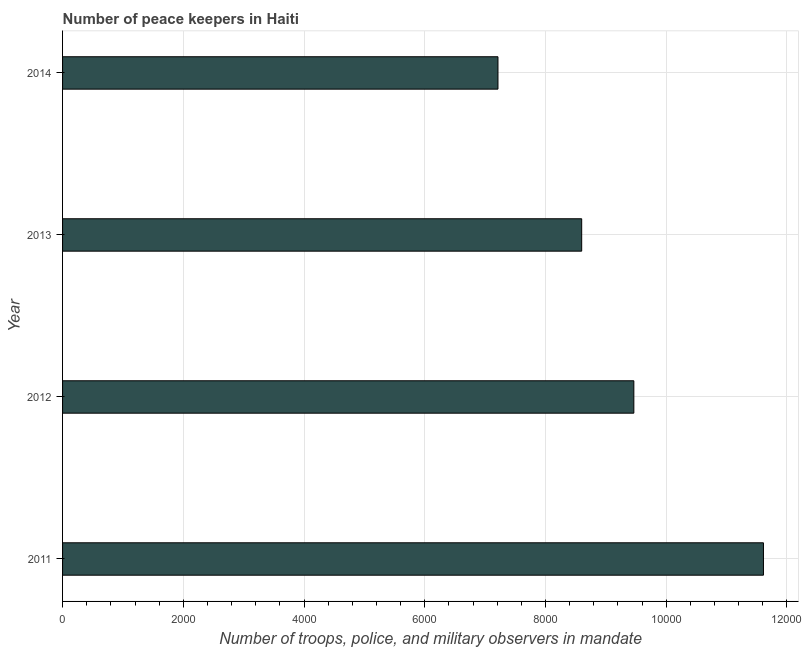Does the graph contain grids?
Make the answer very short. Yes. What is the title of the graph?
Offer a terse response. Number of peace keepers in Haiti. What is the label or title of the X-axis?
Offer a terse response. Number of troops, police, and military observers in mandate. What is the number of peace keepers in 2014?
Provide a short and direct response. 7213. Across all years, what is the maximum number of peace keepers?
Your answer should be compact. 1.16e+04. Across all years, what is the minimum number of peace keepers?
Make the answer very short. 7213. In which year was the number of peace keepers maximum?
Provide a short and direct response. 2011. In which year was the number of peace keepers minimum?
Keep it short and to the point. 2014. What is the sum of the number of peace keepers?
Provide a succinct answer. 3.69e+04. What is the difference between the number of peace keepers in 2011 and 2012?
Offer a terse response. 2147. What is the average number of peace keepers per year?
Make the answer very short. 9222. What is the median number of peace keepers?
Ensure brevity in your answer.  9032. What is the ratio of the number of peace keepers in 2012 to that in 2013?
Your response must be concise. 1.1. Is the number of peace keepers in 2011 less than that in 2014?
Your answer should be compact. No. Is the difference between the number of peace keepers in 2011 and 2014 greater than the difference between any two years?
Keep it short and to the point. Yes. What is the difference between the highest and the second highest number of peace keepers?
Make the answer very short. 2147. Is the sum of the number of peace keepers in 2012 and 2014 greater than the maximum number of peace keepers across all years?
Offer a very short reply. Yes. What is the difference between the highest and the lowest number of peace keepers?
Offer a terse response. 4398. In how many years, is the number of peace keepers greater than the average number of peace keepers taken over all years?
Offer a very short reply. 2. How many bars are there?
Offer a terse response. 4. Are all the bars in the graph horizontal?
Your response must be concise. Yes. Are the values on the major ticks of X-axis written in scientific E-notation?
Offer a terse response. No. What is the Number of troops, police, and military observers in mandate of 2011?
Ensure brevity in your answer.  1.16e+04. What is the Number of troops, police, and military observers in mandate in 2012?
Offer a terse response. 9464. What is the Number of troops, police, and military observers in mandate in 2013?
Provide a short and direct response. 8600. What is the Number of troops, police, and military observers in mandate in 2014?
Give a very brief answer. 7213. What is the difference between the Number of troops, police, and military observers in mandate in 2011 and 2012?
Provide a succinct answer. 2147. What is the difference between the Number of troops, police, and military observers in mandate in 2011 and 2013?
Give a very brief answer. 3011. What is the difference between the Number of troops, police, and military observers in mandate in 2011 and 2014?
Your answer should be very brief. 4398. What is the difference between the Number of troops, police, and military observers in mandate in 2012 and 2013?
Your answer should be very brief. 864. What is the difference between the Number of troops, police, and military observers in mandate in 2012 and 2014?
Make the answer very short. 2251. What is the difference between the Number of troops, police, and military observers in mandate in 2013 and 2014?
Make the answer very short. 1387. What is the ratio of the Number of troops, police, and military observers in mandate in 2011 to that in 2012?
Provide a succinct answer. 1.23. What is the ratio of the Number of troops, police, and military observers in mandate in 2011 to that in 2013?
Your answer should be very brief. 1.35. What is the ratio of the Number of troops, police, and military observers in mandate in 2011 to that in 2014?
Make the answer very short. 1.61. What is the ratio of the Number of troops, police, and military observers in mandate in 2012 to that in 2014?
Provide a short and direct response. 1.31. What is the ratio of the Number of troops, police, and military observers in mandate in 2013 to that in 2014?
Your response must be concise. 1.19. 